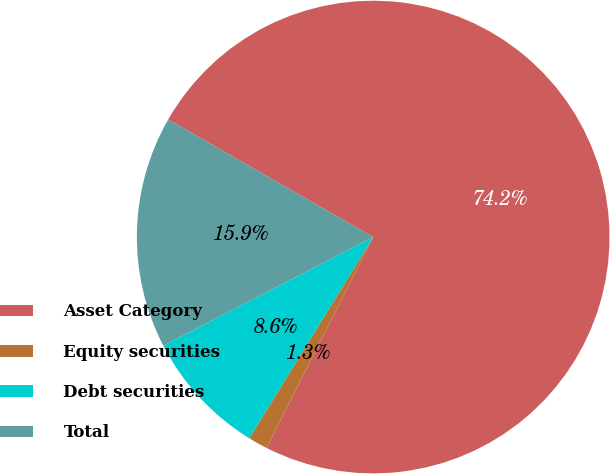<chart> <loc_0><loc_0><loc_500><loc_500><pie_chart><fcel>Asset Category<fcel>Equity securities<fcel>Debt securities<fcel>Total<nl><fcel>74.17%<fcel>1.33%<fcel>8.61%<fcel>15.89%<nl></chart> 